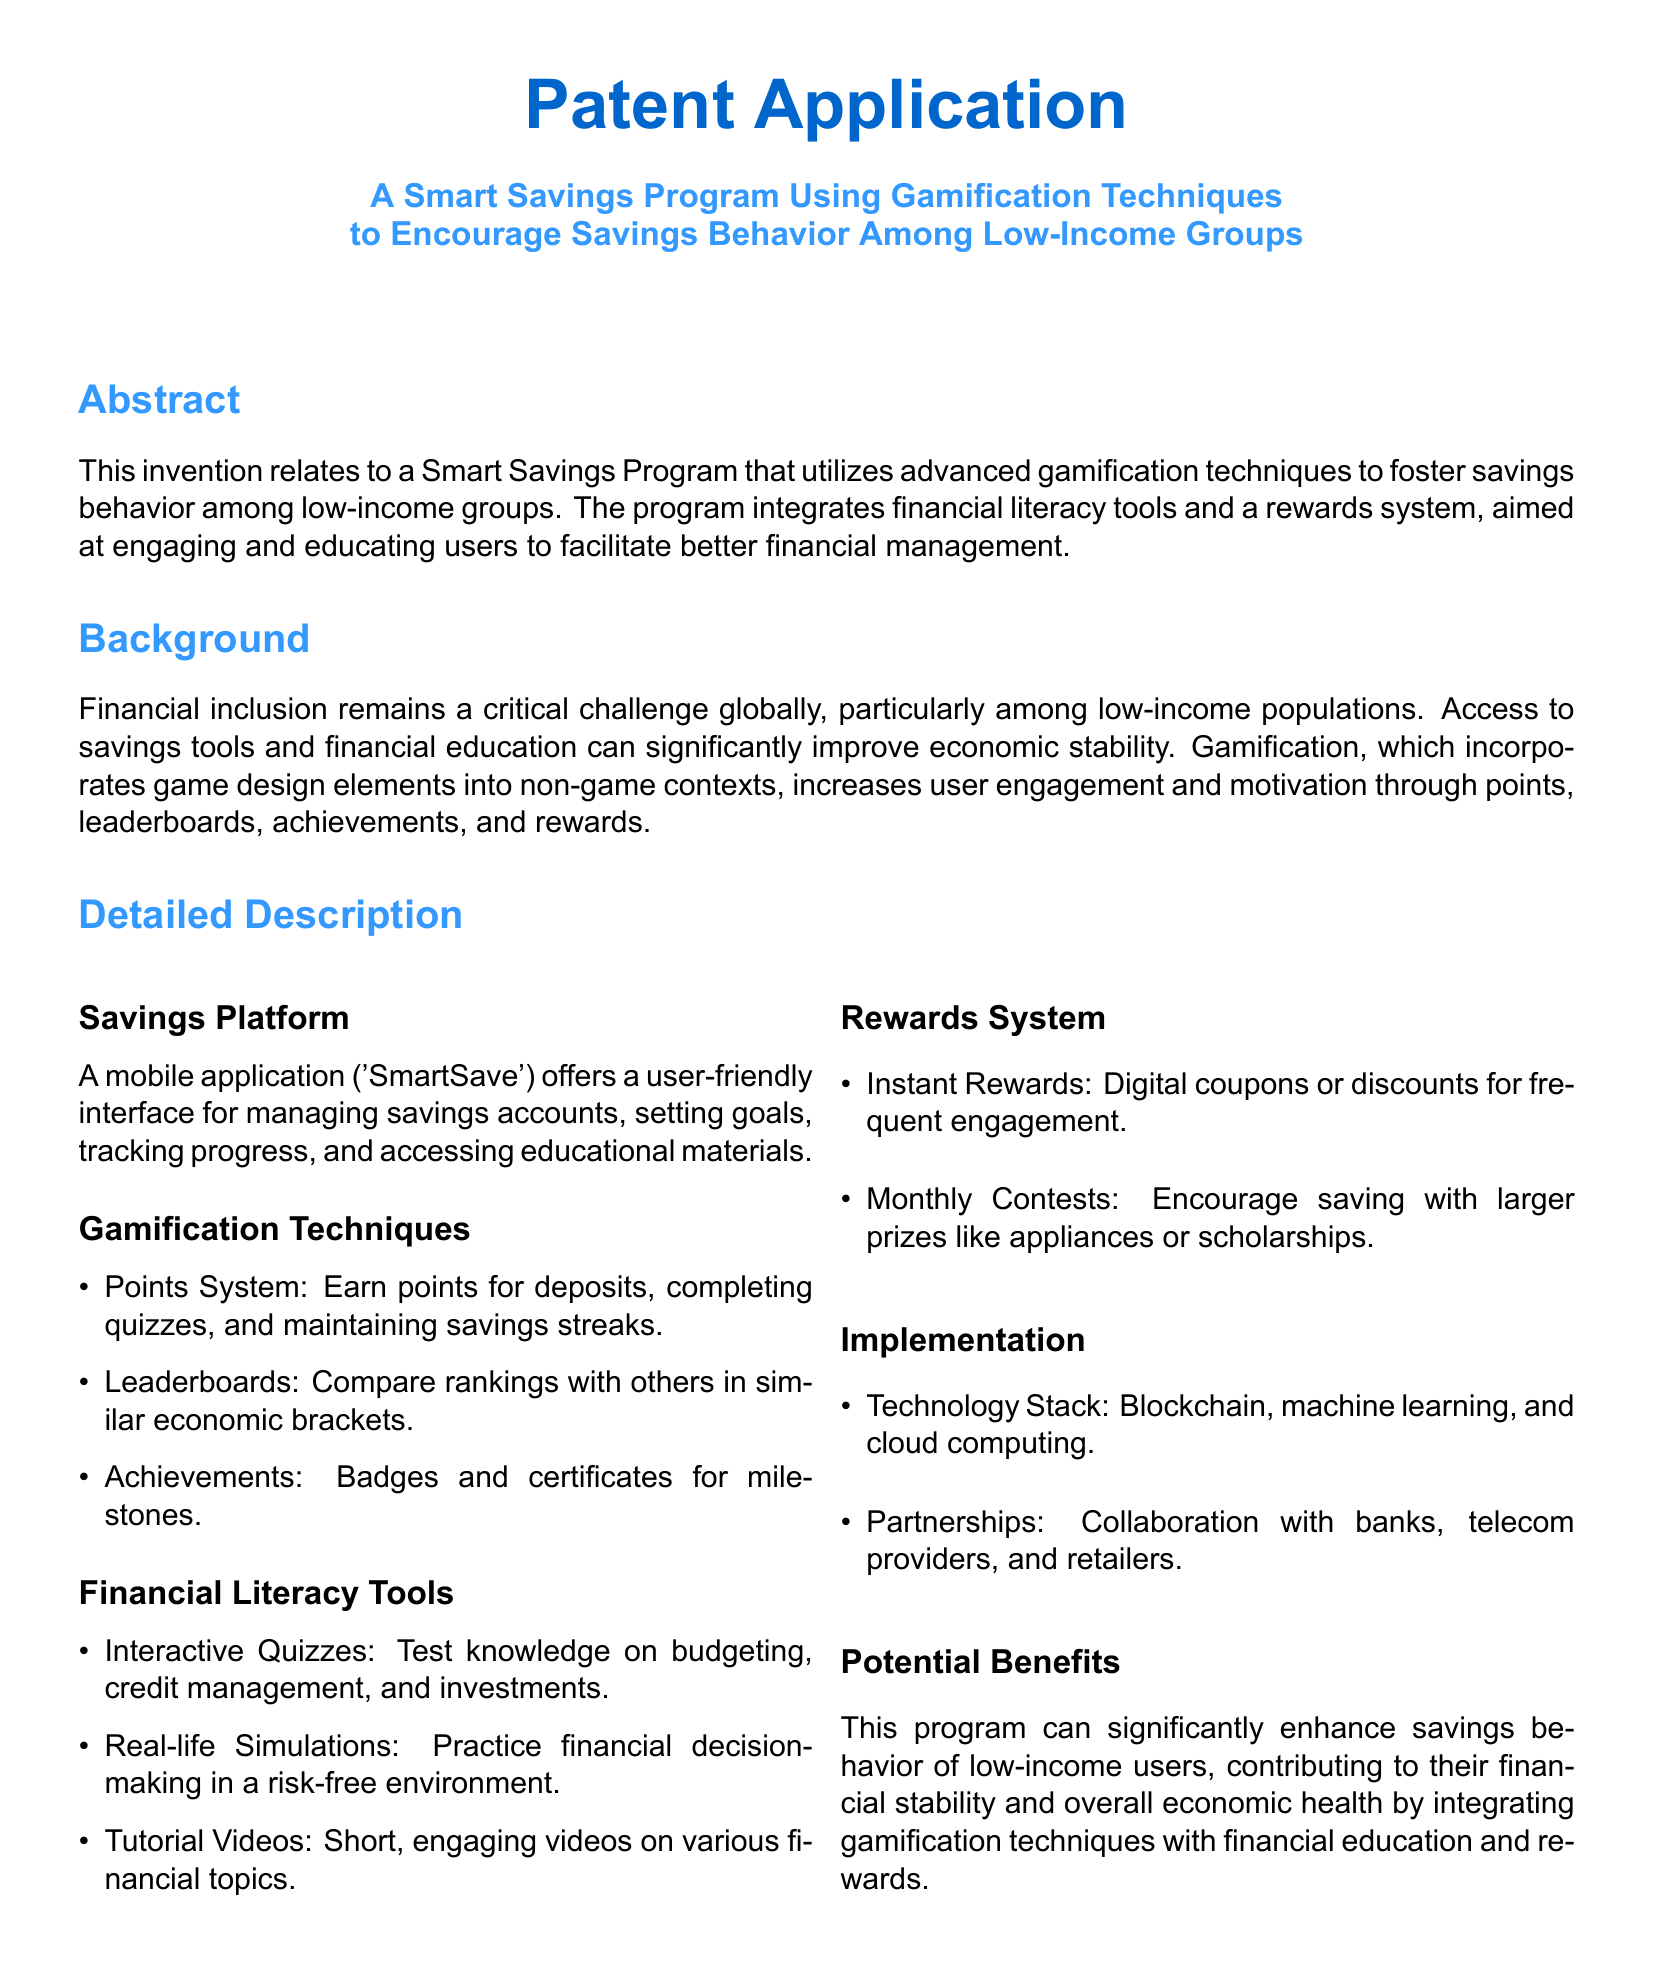What is the title of the patent application? The title of the patent application is presented prominently at the top of the document.
Answer: A Smart Savings Program Using Gamification Techniques to Encourage Savings Behavior Among Low-Income Groups What is the main objective of the Smart Savings Program? The main objective is found in the Abstract section, detailing the purpose of the program.
Answer: To foster savings behavior among low-income groups What gamification technique involves comparing rankings? The document outlines specific gamification techniques under a subheading.
Answer: Leaderboards What type of rewards are given for frequent engagement? The Rewards System section mentions types of rewards that users can earn.
Answer: Digital coupons or discounts Which technology stack does the program incorporate? The Implementation section lists key technologies used in the program.
Answer: Blockchain, machine learning, and cloud computing What kind of quizzes are included for financial literacy? The Financial Literacy Tools section specifies the types of quizzes available.
Answer: Interactive Quizzes What are users encouraged to do through monthly contests? The Rewards System section describes the purpose of monthly contests for users.
Answer: Saving with larger prizes Why is gamification used in this program? The Background section explains the rationale behind using gamification.
Answer: Increases user engagement and motivation What type of partnerships is the program likely to pursue? The Implementation section outlines potential collaborations for the program.
Answer: Collaboration with banks, telecom providers, and retailers 